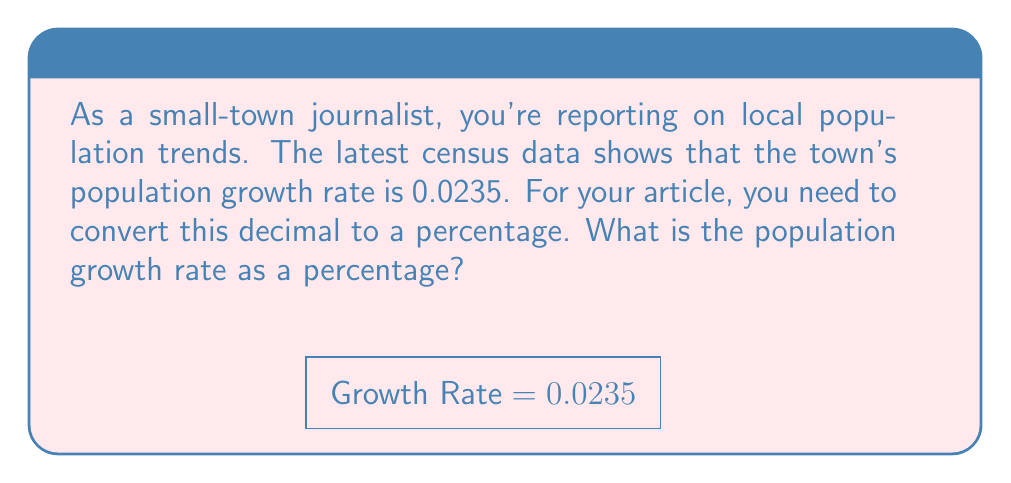Solve this math problem. To convert a decimal to a percentage, we follow these steps:

1) First, we identify the decimal number:
   $0.0235$

2) To convert a decimal to a percentage, we multiply it by 100:
   $0.0235 \times 100 = 2.35$

3) We then add the percentage symbol (%):
   $2.35\%$

This conversion works because percentages represent parts per hundred. By multiplying by 100, we're essentially moving the decimal point two places to the right, which is equivalent to expressing the number as parts per hundred.

In the context of population growth, this means that for every 100 people in the town, the population is increasing by approximately 2.35 people in the given time period.
Answer: $2.35\%$ 